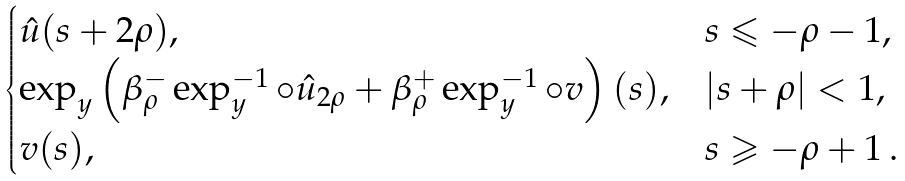Convert formula to latex. <formula><loc_0><loc_0><loc_500><loc_500>\begin{cases} \hat { u } ( s + 2 \rho ) , & s \leqslant - \rho - 1 , \\ \exp _ { y } \left ( \beta ^ { - } _ { \rho } \exp _ { y } ^ { - 1 } \circ \hat { u } _ { 2 \rho } + \beta ^ { + } _ { \rho } \exp _ { y } ^ { - 1 } \circ v \right ) ( s ) , & | s + \rho | < 1 , \\ v ( s ) , & s \geqslant - \rho + 1 \, . \end{cases}</formula> 